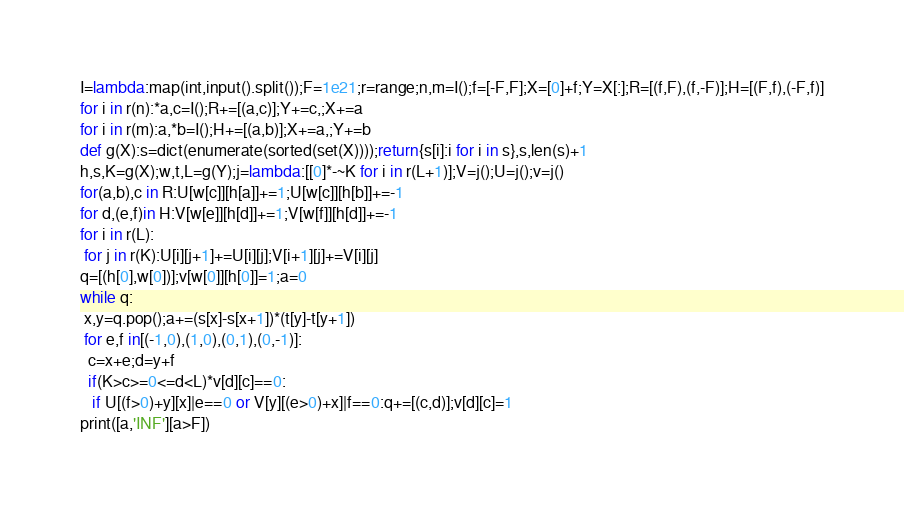Convert code to text. <code><loc_0><loc_0><loc_500><loc_500><_Python_>I=lambda:map(int,input().split());F=1e21;r=range;n,m=I();f=[-F,F];X=[0]+f;Y=X[:];R=[(f,F),(f,-F)];H=[(F,f),(-F,f)]
for i in r(n):*a,c=I();R+=[(a,c)];Y+=c,;X+=a
for i in r(m):a,*b=I();H+=[(a,b)];X+=a,;Y+=b
def g(X):s=dict(enumerate(sorted(set(X))));return{s[i]:i for i in s},s,len(s)+1
h,s,K=g(X);w,t,L=g(Y);j=lambda:[[0]*-~K for i in r(L+1)];V=j();U=j();v=j()
for(a,b),c in R:U[w[c]][h[a]]+=1;U[w[c]][h[b]]+=-1
for d,(e,f)in H:V[w[e]][h[d]]+=1;V[w[f]][h[d]]+=-1
for i in r(L):
 for j in r(K):U[i][j+1]+=U[i][j];V[i+1][j]+=V[i][j]
q=[(h[0],w[0])];v[w[0]][h[0]]=1;a=0
while q:
 x,y=q.pop();a+=(s[x]-s[x+1])*(t[y]-t[y+1])
 for e,f in[(-1,0),(1,0),(0,1),(0,-1)]:
  c=x+e;d=y+f
  if(K>c>=0<=d<L)*v[d][c]==0:
   if U[(f>0)+y][x]|e==0 or V[y][(e>0)+x]|f==0:q+=[(c,d)];v[d][c]=1
print([a,'INF'][a>F])</code> 